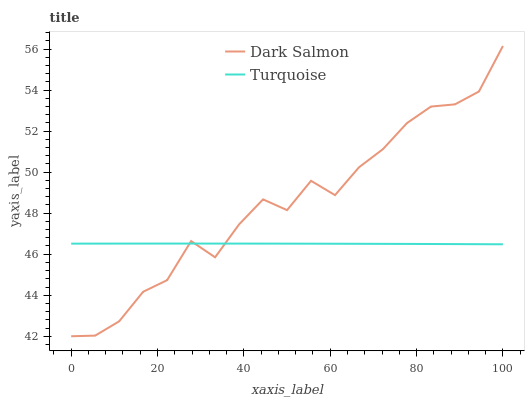Does Dark Salmon have the minimum area under the curve?
Answer yes or no. No. Is Dark Salmon the smoothest?
Answer yes or no. No. 